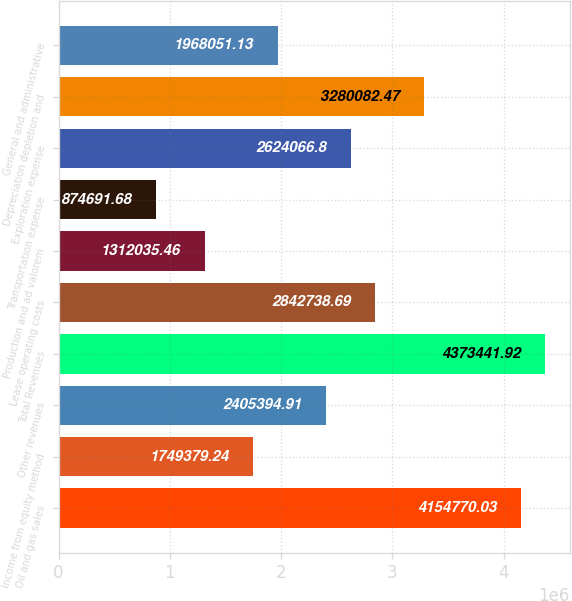Convert chart to OTSL. <chart><loc_0><loc_0><loc_500><loc_500><bar_chart><fcel>Oil and gas sales<fcel>Income from equity method<fcel>Other revenues<fcel>Total Revenues<fcel>Lease operating costs<fcel>Production and ad valorem<fcel>Transportation expense<fcel>Exploration expense<fcel>Depreciation depletion and<fcel>General and administrative<nl><fcel>4.15477e+06<fcel>1.74938e+06<fcel>2.40539e+06<fcel>4.37344e+06<fcel>2.84274e+06<fcel>1.31204e+06<fcel>874692<fcel>2.62407e+06<fcel>3.28008e+06<fcel>1.96805e+06<nl></chart> 